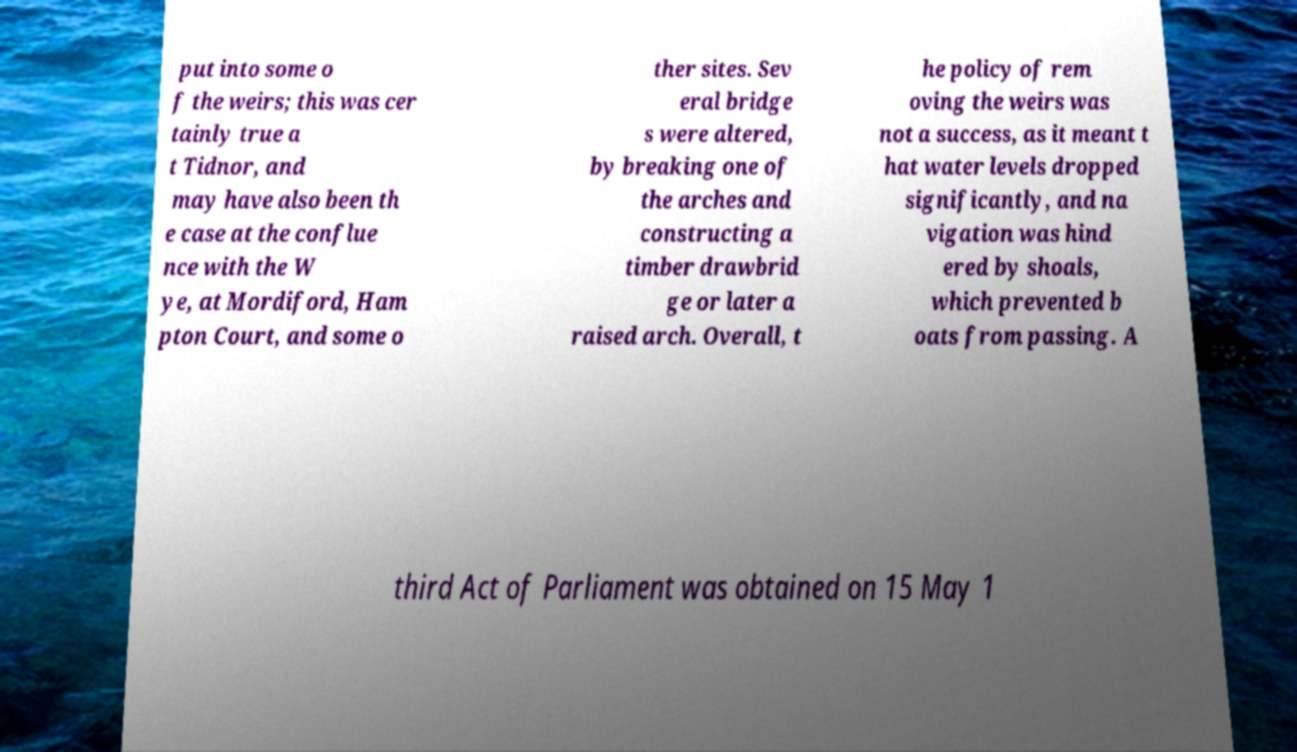Please identify and transcribe the text found in this image. put into some o f the weirs; this was cer tainly true a t Tidnor, and may have also been th e case at the conflue nce with the W ye, at Mordiford, Ham pton Court, and some o ther sites. Sev eral bridge s were altered, by breaking one of the arches and constructing a timber drawbrid ge or later a raised arch. Overall, t he policy of rem oving the weirs was not a success, as it meant t hat water levels dropped significantly, and na vigation was hind ered by shoals, which prevented b oats from passing. A third Act of Parliament was obtained on 15 May 1 